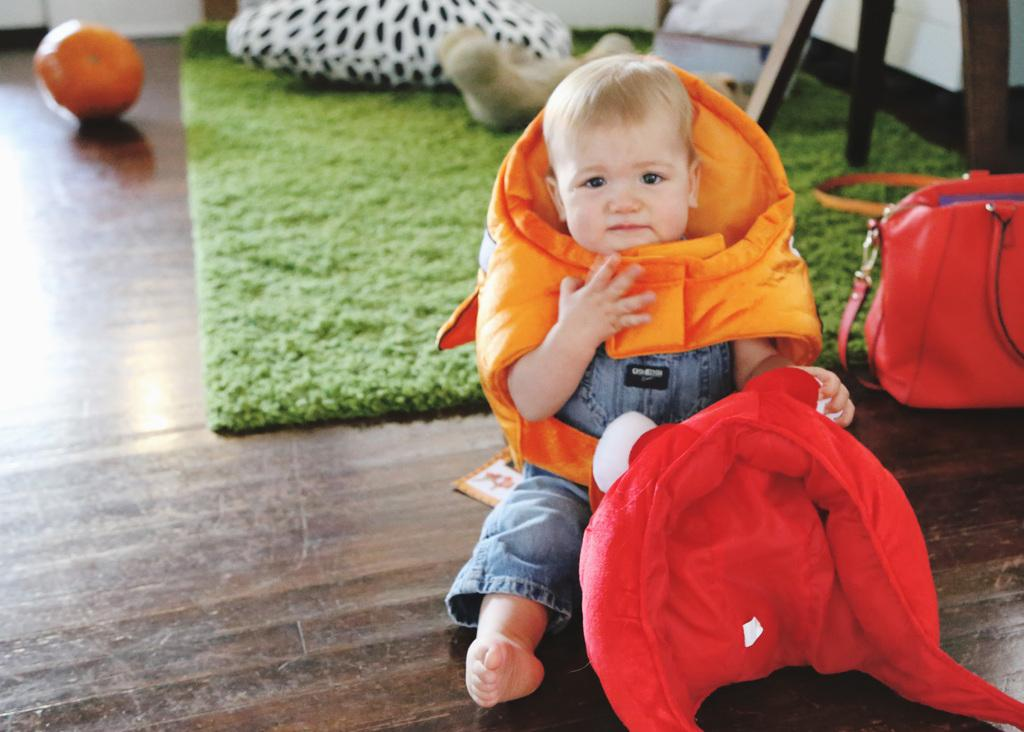What is the baby doing in the image? The baby is sitting on the floor and holding a doll. What can be seen on the right side of the image? There is a handbag on the right side of the image. What type of flooring is visible in the image? There is a carpet in the image. What object can be used for sitting or resting? There is a pillow in the image. What type of furniture is present in the image? There is a chair in the image. What type of food is visible in the image? There are fruits visible in the image. What type of kitten is being treated for a vacation in the image? There is no kitten or mention of treatment or vacation in the image. 